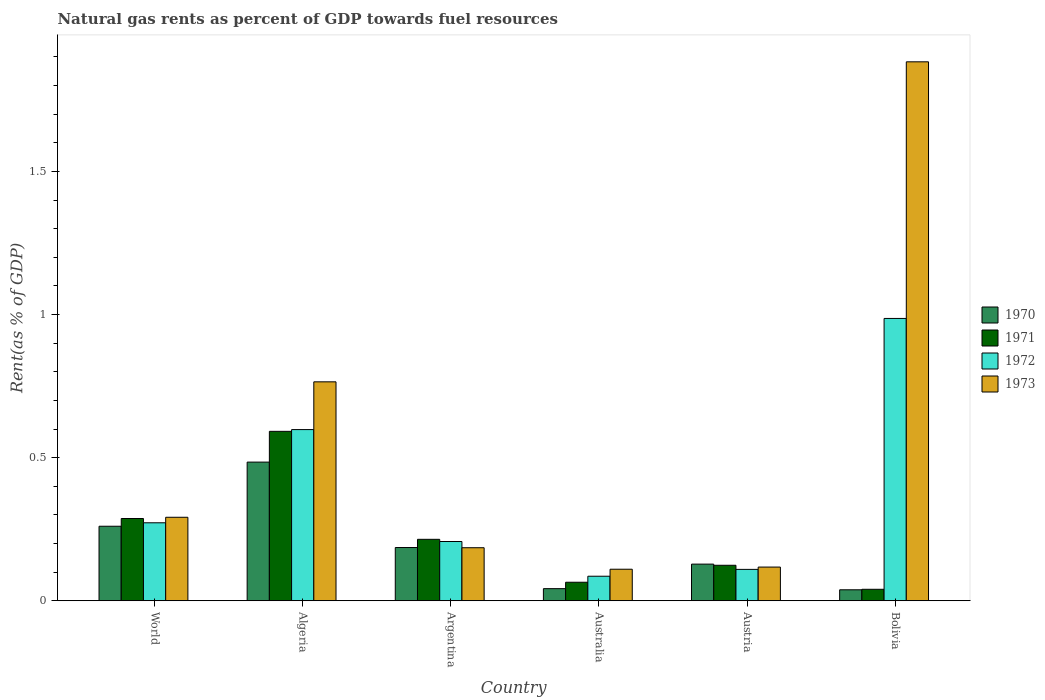Are the number of bars per tick equal to the number of legend labels?
Your answer should be compact. Yes. How many bars are there on the 2nd tick from the right?
Give a very brief answer. 4. What is the matural gas rent in 1973 in World?
Your response must be concise. 0.29. Across all countries, what is the maximum matural gas rent in 1970?
Offer a very short reply. 0.48. Across all countries, what is the minimum matural gas rent in 1970?
Your response must be concise. 0.04. In which country was the matural gas rent in 1973 maximum?
Make the answer very short. Bolivia. What is the total matural gas rent in 1971 in the graph?
Give a very brief answer. 1.32. What is the difference between the matural gas rent in 1973 in Algeria and that in Australia?
Provide a short and direct response. 0.65. What is the difference between the matural gas rent in 1971 in Australia and the matural gas rent in 1970 in Argentina?
Provide a succinct answer. -0.12. What is the average matural gas rent in 1970 per country?
Give a very brief answer. 0.19. What is the difference between the matural gas rent of/in 1972 and matural gas rent of/in 1971 in Austria?
Give a very brief answer. -0.01. In how many countries, is the matural gas rent in 1971 greater than 1.5 %?
Give a very brief answer. 0. What is the ratio of the matural gas rent in 1971 in Algeria to that in Australia?
Provide a short and direct response. 9.14. Is the matural gas rent in 1970 in Algeria less than that in World?
Make the answer very short. No. What is the difference between the highest and the second highest matural gas rent in 1973?
Make the answer very short. -1.12. What is the difference between the highest and the lowest matural gas rent in 1971?
Ensure brevity in your answer.  0.55. Is it the case that in every country, the sum of the matural gas rent in 1973 and matural gas rent in 1972 is greater than the sum of matural gas rent in 1970 and matural gas rent in 1971?
Give a very brief answer. No. What does the 2nd bar from the left in Australia represents?
Keep it short and to the point. 1971. Is it the case that in every country, the sum of the matural gas rent in 1972 and matural gas rent in 1973 is greater than the matural gas rent in 1971?
Give a very brief answer. Yes. How many bars are there?
Your answer should be very brief. 24. Are all the bars in the graph horizontal?
Offer a terse response. No. How many countries are there in the graph?
Your answer should be compact. 6. What is the difference between two consecutive major ticks on the Y-axis?
Your answer should be compact. 0.5. Does the graph contain grids?
Provide a succinct answer. No. How are the legend labels stacked?
Provide a short and direct response. Vertical. What is the title of the graph?
Give a very brief answer. Natural gas rents as percent of GDP towards fuel resources. What is the label or title of the Y-axis?
Your answer should be very brief. Rent(as % of GDP). What is the Rent(as % of GDP) in 1970 in World?
Ensure brevity in your answer.  0.26. What is the Rent(as % of GDP) in 1971 in World?
Make the answer very short. 0.29. What is the Rent(as % of GDP) in 1972 in World?
Offer a terse response. 0.27. What is the Rent(as % of GDP) of 1973 in World?
Provide a short and direct response. 0.29. What is the Rent(as % of GDP) of 1970 in Algeria?
Ensure brevity in your answer.  0.48. What is the Rent(as % of GDP) of 1971 in Algeria?
Your answer should be very brief. 0.59. What is the Rent(as % of GDP) of 1972 in Algeria?
Provide a succinct answer. 0.6. What is the Rent(as % of GDP) of 1973 in Algeria?
Offer a terse response. 0.76. What is the Rent(as % of GDP) in 1970 in Argentina?
Offer a very short reply. 0.19. What is the Rent(as % of GDP) of 1971 in Argentina?
Your answer should be compact. 0.21. What is the Rent(as % of GDP) of 1972 in Argentina?
Your answer should be compact. 0.21. What is the Rent(as % of GDP) of 1973 in Argentina?
Your answer should be compact. 0.19. What is the Rent(as % of GDP) of 1970 in Australia?
Your response must be concise. 0.04. What is the Rent(as % of GDP) of 1971 in Australia?
Give a very brief answer. 0.06. What is the Rent(as % of GDP) of 1972 in Australia?
Ensure brevity in your answer.  0.09. What is the Rent(as % of GDP) of 1973 in Australia?
Your answer should be compact. 0.11. What is the Rent(as % of GDP) of 1970 in Austria?
Your answer should be compact. 0.13. What is the Rent(as % of GDP) of 1971 in Austria?
Keep it short and to the point. 0.12. What is the Rent(as % of GDP) in 1972 in Austria?
Provide a succinct answer. 0.11. What is the Rent(as % of GDP) in 1973 in Austria?
Offer a very short reply. 0.12. What is the Rent(as % of GDP) of 1970 in Bolivia?
Ensure brevity in your answer.  0.04. What is the Rent(as % of GDP) of 1971 in Bolivia?
Offer a very short reply. 0.04. What is the Rent(as % of GDP) in 1972 in Bolivia?
Your response must be concise. 0.99. What is the Rent(as % of GDP) of 1973 in Bolivia?
Make the answer very short. 1.88. Across all countries, what is the maximum Rent(as % of GDP) of 1970?
Give a very brief answer. 0.48. Across all countries, what is the maximum Rent(as % of GDP) in 1971?
Give a very brief answer. 0.59. Across all countries, what is the maximum Rent(as % of GDP) of 1972?
Provide a short and direct response. 0.99. Across all countries, what is the maximum Rent(as % of GDP) in 1973?
Your answer should be compact. 1.88. Across all countries, what is the minimum Rent(as % of GDP) of 1970?
Give a very brief answer. 0.04. Across all countries, what is the minimum Rent(as % of GDP) of 1971?
Your response must be concise. 0.04. Across all countries, what is the minimum Rent(as % of GDP) in 1972?
Your response must be concise. 0.09. Across all countries, what is the minimum Rent(as % of GDP) in 1973?
Your answer should be compact. 0.11. What is the total Rent(as % of GDP) in 1970 in the graph?
Your answer should be compact. 1.14. What is the total Rent(as % of GDP) of 1971 in the graph?
Keep it short and to the point. 1.32. What is the total Rent(as % of GDP) of 1972 in the graph?
Offer a very short reply. 2.26. What is the total Rent(as % of GDP) in 1973 in the graph?
Keep it short and to the point. 3.35. What is the difference between the Rent(as % of GDP) of 1970 in World and that in Algeria?
Offer a terse response. -0.22. What is the difference between the Rent(as % of GDP) in 1971 in World and that in Algeria?
Offer a terse response. -0.3. What is the difference between the Rent(as % of GDP) in 1972 in World and that in Algeria?
Your answer should be very brief. -0.33. What is the difference between the Rent(as % of GDP) of 1973 in World and that in Algeria?
Provide a short and direct response. -0.47. What is the difference between the Rent(as % of GDP) of 1970 in World and that in Argentina?
Make the answer very short. 0.07. What is the difference between the Rent(as % of GDP) of 1971 in World and that in Argentina?
Make the answer very short. 0.07. What is the difference between the Rent(as % of GDP) in 1972 in World and that in Argentina?
Keep it short and to the point. 0.07. What is the difference between the Rent(as % of GDP) in 1973 in World and that in Argentina?
Your answer should be very brief. 0.11. What is the difference between the Rent(as % of GDP) in 1970 in World and that in Australia?
Give a very brief answer. 0.22. What is the difference between the Rent(as % of GDP) of 1971 in World and that in Australia?
Make the answer very short. 0.22. What is the difference between the Rent(as % of GDP) of 1972 in World and that in Australia?
Give a very brief answer. 0.19. What is the difference between the Rent(as % of GDP) in 1973 in World and that in Australia?
Offer a terse response. 0.18. What is the difference between the Rent(as % of GDP) in 1970 in World and that in Austria?
Provide a succinct answer. 0.13. What is the difference between the Rent(as % of GDP) of 1971 in World and that in Austria?
Provide a succinct answer. 0.16. What is the difference between the Rent(as % of GDP) in 1972 in World and that in Austria?
Give a very brief answer. 0.16. What is the difference between the Rent(as % of GDP) in 1973 in World and that in Austria?
Your response must be concise. 0.17. What is the difference between the Rent(as % of GDP) of 1970 in World and that in Bolivia?
Make the answer very short. 0.22. What is the difference between the Rent(as % of GDP) in 1971 in World and that in Bolivia?
Offer a terse response. 0.25. What is the difference between the Rent(as % of GDP) of 1972 in World and that in Bolivia?
Provide a succinct answer. -0.71. What is the difference between the Rent(as % of GDP) of 1973 in World and that in Bolivia?
Your answer should be compact. -1.59. What is the difference between the Rent(as % of GDP) of 1970 in Algeria and that in Argentina?
Give a very brief answer. 0.3. What is the difference between the Rent(as % of GDP) in 1971 in Algeria and that in Argentina?
Offer a very short reply. 0.38. What is the difference between the Rent(as % of GDP) of 1972 in Algeria and that in Argentina?
Keep it short and to the point. 0.39. What is the difference between the Rent(as % of GDP) of 1973 in Algeria and that in Argentina?
Ensure brevity in your answer.  0.58. What is the difference between the Rent(as % of GDP) of 1970 in Algeria and that in Australia?
Your answer should be very brief. 0.44. What is the difference between the Rent(as % of GDP) of 1971 in Algeria and that in Australia?
Give a very brief answer. 0.53. What is the difference between the Rent(as % of GDP) of 1972 in Algeria and that in Australia?
Your answer should be compact. 0.51. What is the difference between the Rent(as % of GDP) of 1973 in Algeria and that in Australia?
Your answer should be compact. 0.65. What is the difference between the Rent(as % of GDP) in 1970 in Algeria and that in Austria?
Your answer should be very brief. 0.36. What is the difference between the Rent(as % of GDP) of 1971 in Algeria and that in Austria?
Make the answer very short. 0.47. What is the difference between the Rent(as % of GDP) in 1972 in Algeria and that in Austria?
Your response must be concise. 0.49. What is the difference between the Rent(as % of GDP) of 1973 in Algeria and that in Austria?
Your answer should be compact. 0.65. What is the difference between the Rent(as % of GDP) of 1970 in Algeria and that in Bolivia?
Make the answer very short. 0.45. What is the difference between the Rent(as % of GDP) in 1971 in Algeria and that in Bolivia?
Offer a terse response. 0.55. What is the difference between the Rent(as % of GDP) of 1972 in Algeria and that in Bolivia?
Ensure brevity in your answer.  -0.39. What is the difference between the Rent(as % of GDP) in 1973 in Algeria and that in Bolivia?
Your answer should be very brief. -1.12. What is the difference between the Rent(as % of GDP) in 1970 in Argentina and that in Australia?
Offer a very short reply. 0.14. What is the difference between the Rent(as % of GDP) of 1971 in Argentina and that in Australia?
Make the answer very short. 0.15. What is the difference between the Rent(as % of GDP) in 1972 in Argentina and that in Australia?
Ensure brevity in your answer.  0.12. What is the difference between the Rent(as % of GDP) of 1973 in Argentina and that in Australia?
Keep it short and to the point. 0.08. What is the difference between the Rent(as % of GDP) in 1970 in Argentina and that in Austria?
Ensure brevity in your answer.  0.06. What is the difference between the Rent(as % of GDP) of 1971 in Argentina and that in Austria?
Offer a very short reply. 0.09. What is the difference between the Rent(as % of GDP) of 1972 in Argentina and that in Austria?
Your response must be concise. 0.1. What is the difference between the Rent(as % of GDP) of 1973 in Argentina and that in Austria?
Offer a terse response. 0.07. What is the difference between the Rent(as % of GDP) of 1970 in Argentina and that in Bolivia?
Give a very brief answer. 0.15. What is the difference between the Rent(as % of GDP) of 1971 in Argentina and that in Bolivia?
Make the answer very short. 0.17. What is the difference between the Rent(as % of GDP) of 1972 in Argentina and that in Bolivia?
Provide a succinct answer. -0.78. What is the difference between the Rent(as % of GDP) of 1973 in Argentina and that in Bolivia?
Give a very brief answer. -1.7. What is the difference between the Rent(as % of GDP) in 1970 in Australia and that in Austria?
Your response must be concise. -0.09. What is the difference between the Rent(as % of GDP) of 1971 in Australia and that in Austria?
Offer a terse response. -0.06. What is the difference between the Rent(as % of GDP) in 1972 in Australia and that in Austria?
Provide a succinct answer. -0.02. What is the difference between the Rent(as % of GDP) of 1973 in Australia and that in Austria?
Your answer should be very brief. -0.01. What is the difference between the Rent(as % of GDP) in 1970 in Australia and that in Bolivia?
Make the answer very short. 0. What is the difference between the Rent(as % of GDP) of 1971 in Australia and that in Bolivia?
Offer a very short reply. 0.02. What is the difference between the Rent(as % of GDP) of 1972 in Australia and that in Bolivia?
Provide a succinct answer. -0.9. What is the difference between the Rent(as % of GDP) of 1973 in Australia and that in Bolivia?
Make the answer very short. -1.77. What is the difference between the Rent(as % of GDP) in 1970 in Austria and that in Bolivia?
Provide a short and direct response. 0.09. What is the difference between the Rent(as % of GDP) of 1971 in Austria and that in Bolivia?
Ensure brevity in your answer.  0.08. What is the difference between the Rent(as % of GDP) of 1972 in Austria and that in Bolivia?
Offer a very short reply. -0.88. What is the difference between the Rent(as % of GDP) of 1973 in Austria and that in Bolivia?
Keep it short and to the point. -1.77. What is the difference between the Rent(as % of GDP) of 1970 in World and the Rent(as % of GDP) of 1971 in Algeria?
Ensure brevity in your answer.  -0.33. What is the difference between the Rent(as % of GDP) in 1970 in World and the Rent(as % of GDP) in 1972 in Algeria?
Provide a short and direct response. -0.34. What is the difference between the Rent(as % of GDP) of 1970 in World and the Rent(as % of GDP) of 1973 in Algeria?
Make the answer very short. -0.5. What is the difference between the Rent(as % of GDP) of 1971 in World and the Rent(as % of GDP) of 1972 in Algeria?
Keep it short and to the point. -0.31. What is the difference between the Rent(as % of GDP) of 1971 in World and the Rent(as % of GDP) of 1973 in Algeria?
Give a very brief answer. -0.48. What is the difference between the Rent(as % of GDP) of 1972 in World and the Rent(as % of GDP) of 1973 in Algeria?
Your response must be concise. -0.49. What is the difference between the Rent(as % of GDP) in 1970 in World and the Rent(as % of GDP) in 1971 in Argentina?
Give a very brief answer. 0.05. What is the difference between the Rent(as % of GDP) of 1970 in World and the Rent(as % of GDP) of 1972 in Argentina?
Provide a succinct answer. 0.05. What is the difference between the Rent(as % of GDP) in 1970 in World and the Rent(as % of GDP) in 1973 in Argentina?
Make the answer very short. 0.07. What is the difference between the Rent(as % of GDP) of 1971 in World and the Rent(as % of GDP) of 1972 in Argentina?
Your response must be concise. 0.08. What is the difference between the Rent(as % of GDP) of 1971 in World and the Rent(as % of GDP) of 1973 in Argentina?
Provide a short and direct response. 0.1. What is the difference between the Rent(as % of GDP) of 1972 in World and the Rent(as % of GDP) of 1973 in Argentina?
Your answer should be compact. 0.09. What is the difference between the Rent(as % of GDP) in 1970 in World and the Rent(as % of GDP) in 1971 in Australia?
Offer a terse response. 0.2. What is the difference between the Rent(as % of GDP) of 1970 in World and the Rent(as % of GDP) of 1972 in Australia?
Provide a short and direct response. 0.17. What is the difference between the Rent(as % of GDP) in 1970 in World and the Rent(as % of GDP) in 1973 in Australia?
Provide a short and direct response. 0.15. What is the difference between the Rent(as % of GDP) of 1971 in World and the Rent(as % of GDP) of 1972 in Australia?
Your answer should be compact. 0.2. What is the difference between the Rent(as % of GDP) in 1971 in World and the Rent(as % of GDP) in 1973 in Australia?
Give a very brief answer. 0.18. What is the difference between the Rent(as % of GDP) in 1972 in World and the Rent(as % of GDP) in 1973 in Australia?
Keep it short and to the point. 0.16. What is the difference between the Rent(as % of GDP) in 1970 in World and the Rent(as % of GDP) in 1971 in Austria?
Offer a terse response. 0.14. What is the difference between the Rent(as % of GDP) in 1970 in World and the Rent(as % of GDP) in 1972 in Austria?
Offer a terse response. 0.15. What is the difference between the Rent(as % of GDP) in 1970 in World and the Rent(as % of GDP) in 1973 in Austria?
Make the answer very short. 0.14. What is the difference between the Rent(as % of GDP) in 1971 in World and the Rent(as % of GDP) in 1972 in Austria?
Your answer should be very brief. 0.18. What is the difference between the Rent(as % of GDP) in 1971 in World and the Rent(as % of GDP) in 1973 in Austria?
Provide a succinct answer. 0.17. What is the difference between the Rent(as % of GDP) in 1972 in World and the Rent(as % of GDP) in 1973 in Austria?
Your response must be concise. 0.15. What is the difference between the Rent(as % of GDP) of 1970 in World and the Rent(as % of GDP) of 1971 in Bolivia?
Make the answer very short. 0.22. What is the difference between the Rent(as % of GDP) in 1970 in World and the Rent(as % of GDP) in 1972 in Bolivia?
Offer a very short reply. -0.73. What is the difference between the Rent(as % of GDP) of 1970 in World and the Rent(as % of GDP) of 1973 in Bolivia?
Your answer should be compact. -1.62. What is the difference between the Rent(as % of GDP) in 1971 in World and the Rent(as % of GDP) in 1972 in Bolivia?
Make the answer very short. -0.7. What is the difference between the Rent(as % of GDP) in 1971 in World and the Rent(as % of GDP) in 1973 in Bolivia?
Make the answer very short. -1.6. What is the difference between the Rent(as % of GDP) of 1972 in World and the Rent(as % of GDP) of 1973 in Bolivia?
Make the answer very short. -1.61. What is the difference between the Rent(as % of GDP) in 1970 in Algeria and the Rent(as % of GDP) in 1971 in Argentina?
Make the answer very short. 0.27. What is the difference between the Rent(as % of GDP) in 1970 in Algeria and the Rent(as % of GDP) in 1972 in Argentina?
Your answer should be compact. 0.28. What is the difference between the Rent(as % of GDP) in 1970 in Algeria and the Rent(as % of GDP) in 1973 in Argentina?
Offer a very short reply. 0.3. What is the difference between the Rent(as % of GDP) in 1971 in Algeria and the Rent(as % of GDP) in 1972 in Argentina?
Give a very brief answer. 0.38. What is the difference between the Rent(as % of GDP) of 1971 in Algeria and the Rent(as % of GDP) of 1973 in Argentina?
Your answer should be compact. 0.41. What is the difference between the Rent(as % of GDP) of 1972 in Algeria and the Rent(as % of GDP) of 1973 in Argentina?
Your answer should be compact. 0.41. What is the difference between the Rent(as % of GDP) of 1970 in Algeria and the Rent(as % of GDP) of 1971 in Australia?
Give a very brief answer. 0.42. What is the difference between the Rent(as % of GDP) of 1970 in Algeria and the Rent(as % of GDP) of 1972 in Australia?
Offer a terse response. 0.4. What is the difference between the Rent(as % of GDP) in 1970 in Algeria and the Rent(as % of GDP) in 1973 in Australia?
Provide a succinct answer. 0.37. What is the difference between the Rent(as % of GDP) in 1971 in Algeria and the Rent(as % of GDP) in 1972 in Australia?
Provide a short and direct response. 0.51. What is the difference between the Rent(as % of GDP) in 1971 in Algeria and the Rent(as % of GDP) in 1973 in Australia?
Your answer should be compact. 0.48. What is the difference between the Rent(as % of GDP) of 1972 in Algeria and the Rent(as % of GDP) of 1973 in Australia?
Your response must be concise. 0.49. What is the difference between the Rent(as % of GDP) of 1970 in Algeria and the Rent(as % of GDP) of 1971 in Austria?
Ensure brevity in your answer.  0.36. What is the difference between the Rent(as % of GDP) in 1970 in Algeria and the Rent(as % of GDP) in 1972 in Austria?
Your answer should be compact. 0.37. What is the difference between the Rent(as % of GDP) of 1970 in Algeria and the Rent(as % of GDP) of 1973 in Austria?
Offer a terse response. 0.37. What is the difference between the Rent(as % of GDP) of 1971 in Algeria and the Rent(as % of GDP) of 1972 in Austria?
Your response must be concise. 0.48. What is the difference between the Rent(as % of GDP) of 1971 in Algeria and the Rent(as % of GDP) of 1973 in Austria?
Offer a terse response. 0.47. What is the difference between the Rent(as % of GDP) of 1972 in Algeria and the Rent(as % of GDP) of 1973 in Austria?
Provide a short and direct response. 0.48. What is the difference between the Rent(as % of GDP) in 1970 in Algeria and the Rent(as % of GDP) in 1971 in Bolivia?
Your answer should be very brief. 0.44. What is the difference between the Rent(as % of GDP) of 1970 in Algeria and the Rent(as % of GDP) of 1972 in Bolivia?
Keep it short and to the point. -0.5. What is the difference between the Rent(as % of GDP) in 1970 in Algeria and the Rent(as % of GDP) in 1973 in Bolivia?
Ensure brevity in your answer.  -1.4. What is the difference between the Rent(as % of GDP) of 1971 in Algeria and the Rent(as % of GDP) of 1972 in Bolivia?
Ensure brevity in your answer.  -0.39. What is the difference between the Rent(as % of GDP) in 1971 in Algeria and the Rent(as % of GDP) in 1973 in Bolivia?
Offer a very short reply. -1.29. What is the difference between the Rent(as % of GDP) in 1972 in Algeria and the Rent(as % of GDP) in 1973 in Bolivia?
Give a very brief answer. -1.28. What is the difference between the Rent(as % of GDP) of 1970 in Argentina and the Rent(as % of GDP) of 1971 in Australia?
Make the answer very short. 0.12. What is the difference between the Rent(as % of GDP) of 1970 in Argentina and the Rent(as % of GDP) of 1972 in Australia?
Provide a succinct answer. 0.1. What is the difference between the Rent(as % of GDP) of 1970 in Argentina and the Rent(as % of GDP) of 1973 in Australia?
Make the answer very short. 0.08. What is the difference between the Rent(as % of GDP) of 1971 in Argentina and the Rent(as % of GDP) of 1972 in Australia?
Give a very brief answer. 0.13. What is the difference between the Rent(as % of GDP) of 1971 in Argentina and the Rent(as % of GDP) of 1973 in Australia?
Your answer should be very brief. 0.1. What is the difference between the Rent(as % of GDP) in 1972 in Argentina and the Rent(as % of GDP) in 1973 in Australia?
Your response must be concise. 0.1. What is the difference between the Rent(as % of GDP) in 1970 in Argentina and the Rent(as % of GDP) in 1971 in Austria?
Offer a very short reply. 0.06. What is the difference between the Rent(as % of GDP) in 1970 in Argentina and the Rent(as % of GDP) in 1972 in Austria?
Your answer should be compact. 0.08. What is the difference between the Rent(as % of GDP) of 1970 in Argentina and the Rent(as % of GDP) of 1973 in Austria?
Provide a succinct answer. 0.07. What is the difference between the Rent(as % of GDP) in 1971 in Argentina and the Rent(as % of GDP) in 1972 in Austria?
Offer a terse response. 0.1. What is the difference between the Rent(as % of GDP) in 1971 in Argentina and the Rent(as % of GDP) in 1973 in Austria?
Keep it short and to the point. 0.1. What is the difference between the Rent(as % of GDP) of 1972 in Argentina and the Rent(as % of GDP) of 1973 in Austria?
Offer a terse response. 0.09. What is the difference between the Rent(as % of GDP) of 1970 in Argentina and the Rent(as % of GDP) of 1971 in Bolivia?
Provide a succinct answer. 0.15. What is the difference between the Rent(as % of GDP) in 1970 in Argentina and the Rent(as % of GDP) in 1972 in Bolivia?
Keep it short and to the point. -0.8. What is the difference between the Rent(as % of GDP) in 1970 in Argentina and the Rent(as % of GDP) in 1973 in Bolivia?
Provide a succinct answer. -1.7. What is the difference between the Rent(as % of GDP) of 1971 in Argentina and the Rent(as % of GDP) of 1972 in Bolivia?
Your answer should be very brief. -0.77. What is the difference between the Rent(as % of GDP) of 1971 in Argentina and the Rent(as % of GDP) of 1973 in Bolivia?
Keep it short and to the point. -1.67. What is the difference between the Rent(as % of GDP) of 1972 in Argentina and the Rent(as % of GDP) of 1973 in Bolivia?
Ensure brevity in your answer.  -1.68. What is the difference between the Rent(as % of GDP) in 1970 in Australia and the Rent(as % of GDP) in 1971 in Austria?
Ensure brevity in your answer.  -0.08. What is the difference between the Rent(as % of GDP) of 1970 in Australia and the Rent(as % of GDP) of 1972 in Austria?
Make the answer very short. -0.07. What is the difference between the Rent(as % of GDP) of 1970 in Australia and the Rent(as % of GDP) of 1973 in Austria?
Your answer should be compact. -0.08. What is the difference between the Rent(as % of GDP) of 1971 in Australia and the Rent(as % of GDP) of 1972 in Austria?
Ensure brevity in your answer.  -0.04. What is the difference between the Rent(as % of GDP) in 1971 in Australia and the Rent(as % of GDP) in 1973 in Austria?
Provide a succinct answer. -0.05. What is the difference between the Rent(as % of GDP) of 1972 in Australia and the Rent(as % of GDP) of 1973 in Austria?
Your response must be concise. -0.03. What is the difference between the Rent(as % of GDP) in 1970 in Australia and the Rent(as % of GDP) in 1971 in Bolivia?
Give a very brief answer. 0. What is the difference between the Rent(as % of GDP) of 1970 in Australia and the Rent(as % of GDP) of 1972 in Bolivia?
Your response must be concise. -0.94. What is the difference between the Rent(as % of GDP) of 1970 in Australia and the Rent(as % of GDP) of 1973 in Bolivia?
Your answer should be compact. -1.84. What is the difference between the Rent(as % of GDP) of 1971 in Australia and the Rent(as % of GDP) of 1972 in Bolivia?
Your answer should be compact. -0.92. What is the difference between the Rent(as % of GDP) in 1971 in Australia and the Rent(as % of GDP) in 1973 in Bolivia?
Ensure brevity in your answer.  -1.82. What is the difference between the Rent(as % of GDP) of 1972 in Australia and the Rent(as % of GDP) of 1973 in Bolivia?
Your answer should be very brief. -1.8. What is the difference between the Rent(as % of GDP) of 1970 in Austria and the Rent(as % of GDP) of 1971 in Bolivia?
Your answer should be compact. 0.09. What is the difference between the Rent(as % of GDP) in 1970 in Austria and the Rent(as % of GDP) in 1972 in Bolivia?
Make the answer very short. -0.86. What is the difference between the Rent(as % of GDP) in 1970 in Austria and the Rent(as % of GDP) in 1973 in Bolivia?
Offer a very short reply. -1.75. What is the difference between the Rent(as % of GDP) in 1971 in Austria and the Rent(as % of GDP) in 1972 in Bolivia?
Your response must be concise. -0.86. What is the difference between the Rent(as % of GDP) in 1971 in Austria and the Rent(as % of GDP) in 1973 in Bolivia?
Ensure brevity in your answer.  -1.76. What is the difference between the Rent(as % of GDP) in 1972 in Austria and the Rent(as % of GDP) in 1973 in Bolivia?
Provide a succinct answer. -1.77. What is the average Rent(as % of GDP) in 1970 per country?
Make the answer very short. 0.19. What is the average Rent(as % of GDP) of 1971 per country?
Keep it short and to the point. 0.22. What is the average Rent(as % of GDP) in 1972 per country?
Your answer should be compact. 0.38. What is the average Rent(as % of GDP) of 1973 per country?
Give a very brief answer. 0.56. What is the difference between the Rent(as % of GDP) in 1970 and Rent(as % of GDP) in 1971 in World?
Give a very brief answer. -0.03. What is the difference between the Rent(as % of GDP) in 1970 and Rent(as % of GDP) in 1972 in World?
Offer a terse response. -0.01. What is the difference between the Rent(as % of GDP) in 1970 and Rent(as % of GDP) in 1973 in World?
Offer a very short reply. -0.03. What is the difference between the Rent(as % of GDP) in 1971 and Rent(as % of GDP) in 1972 in World?
Your answer should be very brief. 0.01. What is the difference between the Rent(as % of GDP) of 1971 and Rent(as % of GDP) of 1973 in World?
Your response must be concise. -0. What is the difference between the Rent(as % of GDP) in 1972 and Rent(as % of GDP) in 1973 in World?
Offer a very short reply. -0.02. What is the difference between the Rent(as % of GDP) in 1970 and Rent(as % of GDP) in 1971 in Algeria?
Keep it short and to the point. -0.11. What is the difference between the Rent(as % of GDP) of 1970 and Rent(as % of GDP) of 1972 in Algeria?
Ensure brevity in your answer.  -0.11. What is the difference between the Rent(as % of GDP) in 1970 and Rent(as % of GDP) in 1973 in Algeria?
Your answer should be compact. -0.28. What is the difference between the Rent(as % of GDP) in 1971 and Rent(as % of GDP) in 1972 in Algeria?
Your response must be concise. -0.01. What is the difference between the Rent(as % of GDP) in 1971 and Rent(as % of GDP) in 1973 in Algeria?
Your answer should be very brief. -0.17. What is the difference between the Rent(as % of GDP) of 1972 and Rent(as % of GDP) of 1973 in Algeria?
Your response must be concise. -0.17. What is the difference between the Rent(as % of GDP) of 1970 and Rent(as % of GDP) of 1971 in Argentina?
Provide a succinct answer. -0.03. What is the difference between the Rent(as % of GDP) of 1970 and Rent(as % of GDP) of 1972 in Argentina?
Make the answer very short. -0.02. What is the difference between the Rent(as % of GDP) of 1970 and Rent(as % of GDP) of 1973 in Argentina?
Offer a terse response. 0. What is the difference between the Rent(as % of GDP) in 1971 and Rent(as % of GDP) in 1972 in Argentina?
Make the answer very short. 0.01. What is the difference between the Rent(as % of GDP) of 1971 and Rent(as % of GDP) of 1973 in Argentina?
Provide a short and direct response. 0.03. What is the difference between the Rent(as % of GDP) in 1972 and Rent(as % of GDP) in 1973 in Argentina?
Your response must be concise. 0.02. What is the difference between the Rent(as % of GDP) of 1970 and Rent(as % of GDP) of 1971 in Australia?
Your answer should be very brief. -0.02. What is the difference between the Rent(as % of GDP) in 1970 and Rent(as % of GDP) in 1972 in Australia?
Give a very brief answer. -0.04. What is the difference between the Rent(as % of GDP) of 1970 and Rent(as % of GDP) of 1973 in Australia?
Give a very brief answer. -0.07. What is the difference between the Rent(as % of GDP) in 1971 and Rent(as % of GDP) in 1972 in Australia?
Make the answer very short. -0.02. What is the difference between the Rent(as % of GDP) of 1971 and Rent(as % of GDP) of 1973 in Australia?
Ensure brevity in your answer.  -0.05. What is the difference between the Rent(as % of GDP) in 1972 and Rent(as % of GDP) in 1973 in Australia?
Your response must be concise. -0.02. What is the difference between the Rent(as % of GDP) of 1970 and Rent(as % of GDP) of 1971 in Austria?
Your response must be concise. 0. What is the difference between the Rent(as % of GDP) in 1970 and Rent(as % of GDP) in 1972 in Austria?
Make the answer very short. 0.02. What is the difference between the Rent(as % of GDP) in 1970 and Rent(as % of GDP) in 1973 in Austria?
Your answer should be very brief. 0.01. What is the difference between the Rent(as % of GDP) in 1971 and Rent(as % of GDP) in 1972 in Austria?
Your answer should be very brief. 0.01. What is the difference between the Rent(as % of GDP) in 1971 and Rent(as % of GDP) in 1973 in Austria?
Your response must be concise. 0.01. What is the difference between the Rent(as % of GDP) of 1972 and Rent(as % of GDP) of 1973 in Austria?
Offer a terse response. -0.01. What is the difference between the Rent(as % of GDP) in 1970 and Rent(as % of GDP) in 1971 in Bolivia?
Your answer should be very brief. -0. What is the difference between the Rent(as % of GDP) of 1970 and Rent(as % of GDP) of 1972 in Bolivia?
Your answer should be compact. -0.95. What is the difference between the Rent(as % of GDP) of 1970 and Rent(as % of GDP) of 1973 in Bolivia?
Ensure brevity in your answer.  -1.84. What is the difference between the Rent(as % of GDP) of 1971 and Rent(as % of GDP) of 1972 in Bolivia?
Make the answer very short. -0.95. What is the difference between the Rent(as % of GDP) in 1971 and Rent(as % of GDP) in 1973 in Bolivia?
Your response must be concise. -1.84. What is the difference between the Rent(as % of GDP) of 1972 and Rent(as % of GDP) of 1973 in Bolivia?
Keep it short and to the point. -0.9. What is the ratio of the Rent(as % of GDP) of 1970 in World to that in Algeria?
Provide a succinct answer. 0.54. What is the ratio of the Rent(as % of GDP) of 1971 in World to that in Algeria?
Offer a very short reply. 0.49. What is the ratio of the Rent(as % of GDP) of 1972 in World to that in Algeria?
Make the answer very short. 0.46. What is the ratio of the Rent(as % of GDP) of 1973 in World to that in Algeria?
Offer a terse response. 0.38. What is the ratio of the Rent(as % of GDP) of 1970 in World to that in Argentina?
Your answer should be compact. 1.4. What is the ratio of the Rent(as % of GDP) of 1971 in World to that in Argentina?
Offer a very short reply. 1.34. What is the ratio of the Rent(as % of GDP) of 1972 in World to that in Argentina?
Make the answer very short. 1.32. What is the ratio of the Rent(as % of GDP) in 1973 in World to that in Argentina?
Make the answer very short. 1.57. What is the ratio of the Rent(as % of GDP) in 1970 in World to that in Australia?
Provide a short and direct response. 6.15. What is the ratio of the Rent(as % of GDP) of 1971 in World to that in Australia?
Your answer should be very brief. 4.44. What is the ratio of the Rent(as % of GDP) in 1972 in World to that in Australia?
Make the answer very short. 3.18. What is the ratio of the Rent(as % of GDP) in 1973 in World to that in Australia?
Give a very brief answer. 2.65. What is the ratio of the Rent(as % of GDP) of 1970 in World to that in Austria?
Offer a terse response. 2.03. What is the ratio of the Rent(as % of GDP) in 1971 in World to that in Austria?
Your response must be concise. 2.32. What is the ratio of the Rent(as % of GDP) in 1972 in World to that in Austria?
Provide a short and direct response. 2.48. What is the ratio of the Rent(as % of GDP) of 1973 in World to that in Austria?
Your response must be concise. 2.48. What is the ratio of the Rent(as % of GDP) in 1970 in World to that in Bolivia?
Keep it short and to the point. 6.78. What is the ratio of the Rent(as % of GDP) in 1971 in World to that in Bolivia?
Keep it short and to the point. 7.16. What is the ratio of the Rent(as % of GDP) in 1972 in World to that in Bolivia?
Your answer should be very brief. 0.28. What is the ratio of the Rent(as % of GDP) in 1973 in World to that in Bolivia?
Offer a very short reply. 0.15. What is the ratio of the Rent(as % of GDP) in 1970 in Algeria to that in Argentina?
Your response must be concise. 2.6. What is the ratio of the Rent(as % of GDP) of 1971 in Algeria to that in Argentina?
Your answer should be compact. 2.76. What is the ratio of the Rent(as % of GDP) of 1972 in Algeria to that in Argentina?
Offer a terse response. 2.89. What is the ratio of the Rent(as % of GDP) in 1973 in Algeria to that in Argentina?
Make the answer very short. 4.13. What is the ratio of the Rent(as % of GDP) in 1970 in Algeria to that in Australia?
Your answer should be compact. 11.44. What is the ratio of the Rent(as % of GDP) of 1971 in Algeria to that in Australia?
Your answer should be compact. 9.14. What is the ratio of the Rent(as % of GDP) of 1972 in Algeria to that in Australia?
Give a very brief answer. 6.97. What is the ratio of the Rent(as % of GDP) of 1973 in Algeria to that in Australia?
Provide a succinct answer. 6.94. What is the ratio of the Rent(as % of GDP) in 1970 in Algeria to that in Austria?
Make the answer very short. 3.78. What is the ratio of the Rent(as % of GDP) of 1971 in Algeria to that in Austria?
Provide a succinct answer. 4.77. What is the ratio of the Rent(as % of GDP) of 1972 in Algeria to that in Austria?
Your answer should be compact. 5.45. What is the ratio of the Rent(as % of GDP) in 1973 in Algeria to that in Austria?
Keep it short and to the point. 6.5. What is the ratio of the Rent(as % of GDP) in 1970 in Algeria to that in Bolivia?
Offer a terse response. 12.62. What is the ratio of the Rent(as % of GDP) in 1971 in Algeria to that in Bolivia?
Your answer should be compact. 14.75. What is the ratio of the Rent(as % of GDP) in 1972 in Algeria to that in Bolivia?
Your response must be concise. 0.61. What is the ratio of the Rent(as % of GDP) in 1973 in Algeria to that in Bolivia?
Keep it short and to the point. 0.41. What is the ratio of the Rent(as % of GDP) of 1970 in Argentina to that in Australia?
Your answer should be compact. 4.39. What is the ratio of the Rent(as % of GDP) of 1971 in Argentina to that in Australia?
Ensure brevity in your answer.  3.32. What is the ratio of the Rent(as % of GDP) in 1972 in Argentina to that in Australia?
Ensure brevity in your answer.  2.41. What is the ratio of the Rent(as % of GDP) of 1973 in Argentina to that in Australia?
Make the answer very short. 1.68. What is the ratio of the Rent(as % of GDP) of 1970 in Argentina to that in Austria?
Provide a succinct answer. 1.45. What is the ratio of the Rent(as % of GDP) in 1971 in Argentina to that in Austria?
Ensure brevity in your answer.  1.73. What is the ratio of the Rent(as % of GDP) in 1972 in Argentina to that in Austria?
Ensure brevity in your answer.  1.89. What is the ratio of the Rent(as % of GDP) of 1973 in Argentina to that in Austria?
Your response must be concise. 1.57. What is the ratio of the Rent(as % of GDP) in 1970 in Argentina to that in Bolivia?
Provide a short and direct response. 4.85. What is the ratio of the Rent(as % of GDP) of 1971 in Argentina to that in Bolivia?
Make the answer very short. 5.35. What is the ratio of the Rent(as % of GDP) of 1972 in Argentina to that in Bolivia?
Give a very brief answer. 0.21. What is the ratio of the Rent(as % of GDP) of 1973 in Argentina to that in Bolivia?
Give a very brief answer. 0.1. What is the ratio of the Rent(as % of GDP) of 1970 in Australia to that in Austria?
Your response must be concise. 0.33. What is the ratio of the Rent(as % of GDP) in 1971 in Australia to that in Austria?
Your answer should be compact. 0.52. What is the ratio of the Rent(as % of GDP) of 1972 in Australia to that in Austria?
Keep it short and to the point. 0.78. What is the ratio of the Rent(as % of GDP) in 1973 in Australia to that in Austria?
Your answer should be compact. 0.94. What is the ratio of the Rent(as % of GDP) of 1970 in Australia to that in Bolivia?
Provide a short and direct response. 1.1. What is the ratio of the Rent(as % of GDP) in 1971 in Australia to that in Bolivia?
Provide a succinct answer. 1.61. What is the ratio of the Rent(as % of GDP) in 1972 in Australia to that in Bolivia?
Ensure brevity in your answer.  0.09. What is the ratio of the Rent(as % of GDP) in 1973 in Australia to that in Bolivia?
Your answer should be compact. 0.06. What is the ratio of the Rent(as % of GDP) of 1970 in Austria to that in Bolivia?
Give a very brief answer. 3.34. What is the ratio of the Rent(as % of GDP) in 1971 in Austria to that in Bolivia?
Ensure brevity in your answer.  3.09. What is the ratio of the Rent(as % of GDP) of 1972 in Austria to that in Bolivia?
Your response must be concise. 0.11. What is the ratio of the Rent(as % of GDP) of 1973 in Austria to that in Bolivia?
Your answer should be very brief. 0.06. What is the difference between the highest and the second highest Rent(as % of GDP) in 1970?
Your answer should be very brief. 0.22. What is the difference between the highest and the second highest Rent(as % of GDP) of 1971?
Provide a short and direct response. 0.3. What is the difference between the highest and the second highest Rent(as % of GDP) in 1972?
Your answer should be very brief. 0.39. What is the difference between the highest and the second highest Rent(as % of GDP) of 1973?
Your answer should be very brief. 1.12. What is the difference between the highest and the lowest Rent(as % of GDP) of 1970?
Make the answer very short. 0.45. What is the difference between the highest and the lowest Rent(as % of GDP) of 1971?
Your answer should be very brief. 0.55. What is the difference between the highest and the lowest Rent(as % of GDP) of 1972?
Your answer should be compact. 0.9. What is the difference between the highest and the lowest Rent(as % of GDP) in 1973?
Offer a terse response. 1.77. 